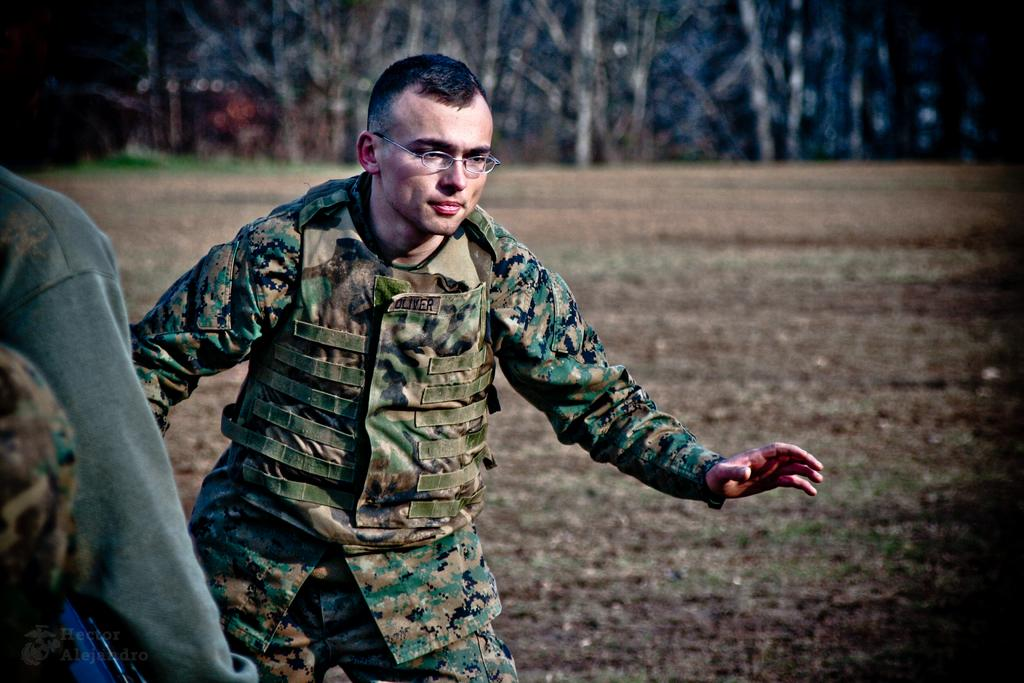What is the main subject of the image? There is a person standing in the image. What is the person wearing? The person is wearing an army dress and glasses. Is there any text visible on the person's clothing? Yes, the name "Oliver" is visible on the person's shirt. What type of square object is being used by the person in the image? There is no square object visible in the image. What is the person using to eat their meal in the image? The image does not show the person eating a meal or using a fork. 